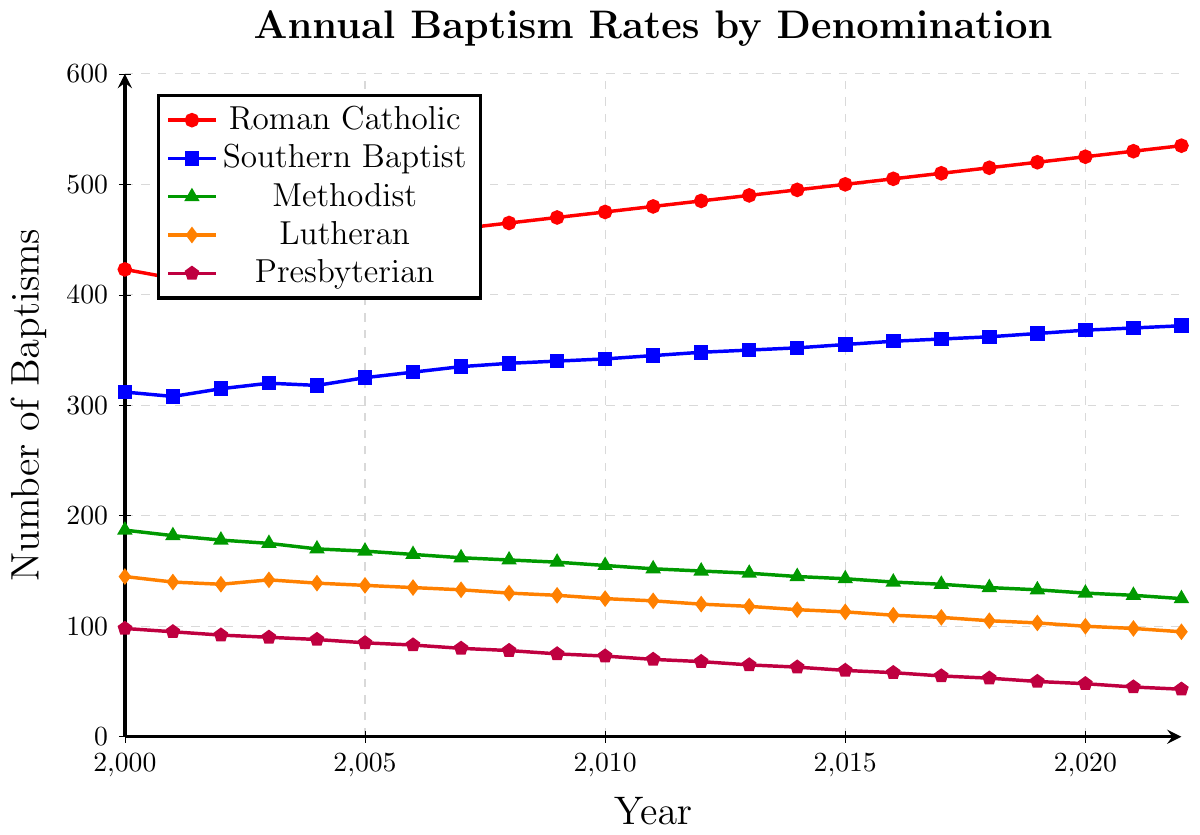What is the total number of baptisms for the Roman Catholic denomination in the years 2005 and 2006 combined? Sum the number of baptisms for 2005 and 2006 from the Roman Catholic data series. That gives (450 + 455)
Answer: 905 Which denomination had the highest number of baptisms in the year 2010? Compare the baptism numbers for all denominations in 2010. Roman Catholic had the highest with 475.
Answer: Roman Catholic What is the trend of baptism rates for the Presbyterian denomination over the given years? Observing the data for Presbyterians from 2000 to 2022 shows a gradual decline in the number of baptisms. Starting from 98 in 2000 and ending at 43 in 2022.
Answer: Downward trend In which year did the Southern Baptist denomination reach 362 baptisms? Locate the point where the Southern Baptist line intersects 362 on the y-axis. This occurs in the year 2018.
Answer: 2018 How many more baptisms were there in the Southern Baptist denomination than in the Lutheran denomination in 2022? Subtract the number of Lutheran baptisms from the Southern Baptist baptisms in 2022 (372 - 95).
Answer: 277 Which two denominations show a consistent increase in their baptism rates throughout the years? By examining the trends, both the Roman Catholic and Southern Baptist denominations show consistent increasing trends from 2000 to 2022.
Answer: Roman Catholic and Southern Baptist What is the overall percentage increase in the number of Methodist baptisms from 2000 to 2022? Calculate the percentage increase: ((125 - 187) / 187) * 100. This is approximately -33.2%, indicating a decrease rather than an increase.
Answer: -33.2% How do the baptism rates of the Lutheran denomination in 2020 compare with those in 2010? Look at the figures for Lutheran baptisms in 2020 (100) and 2010 (125). The number of baptisms decreased by 25.
Answer: Decreased by 25 What is the median number of baptisms for the Southern Baptist denomination from 2000 to 2022? Arrange the Southern Baptist data points in ascending order and find the middle value. In this case, the middle value (median) is around 348.
Answer: 348 Identify the year in which the Roman Catholic denomination had exactly 500 baptisms. Find the year in the Roman Catholic data series that corresponds to exactly 500 baptisms, which is 2015.
Answer: 2015 